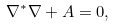<formula> <loc_0><loc_0><loc_500><loc_500>\nabla ^ { * } \nabla + A = 0 ,</formula> 